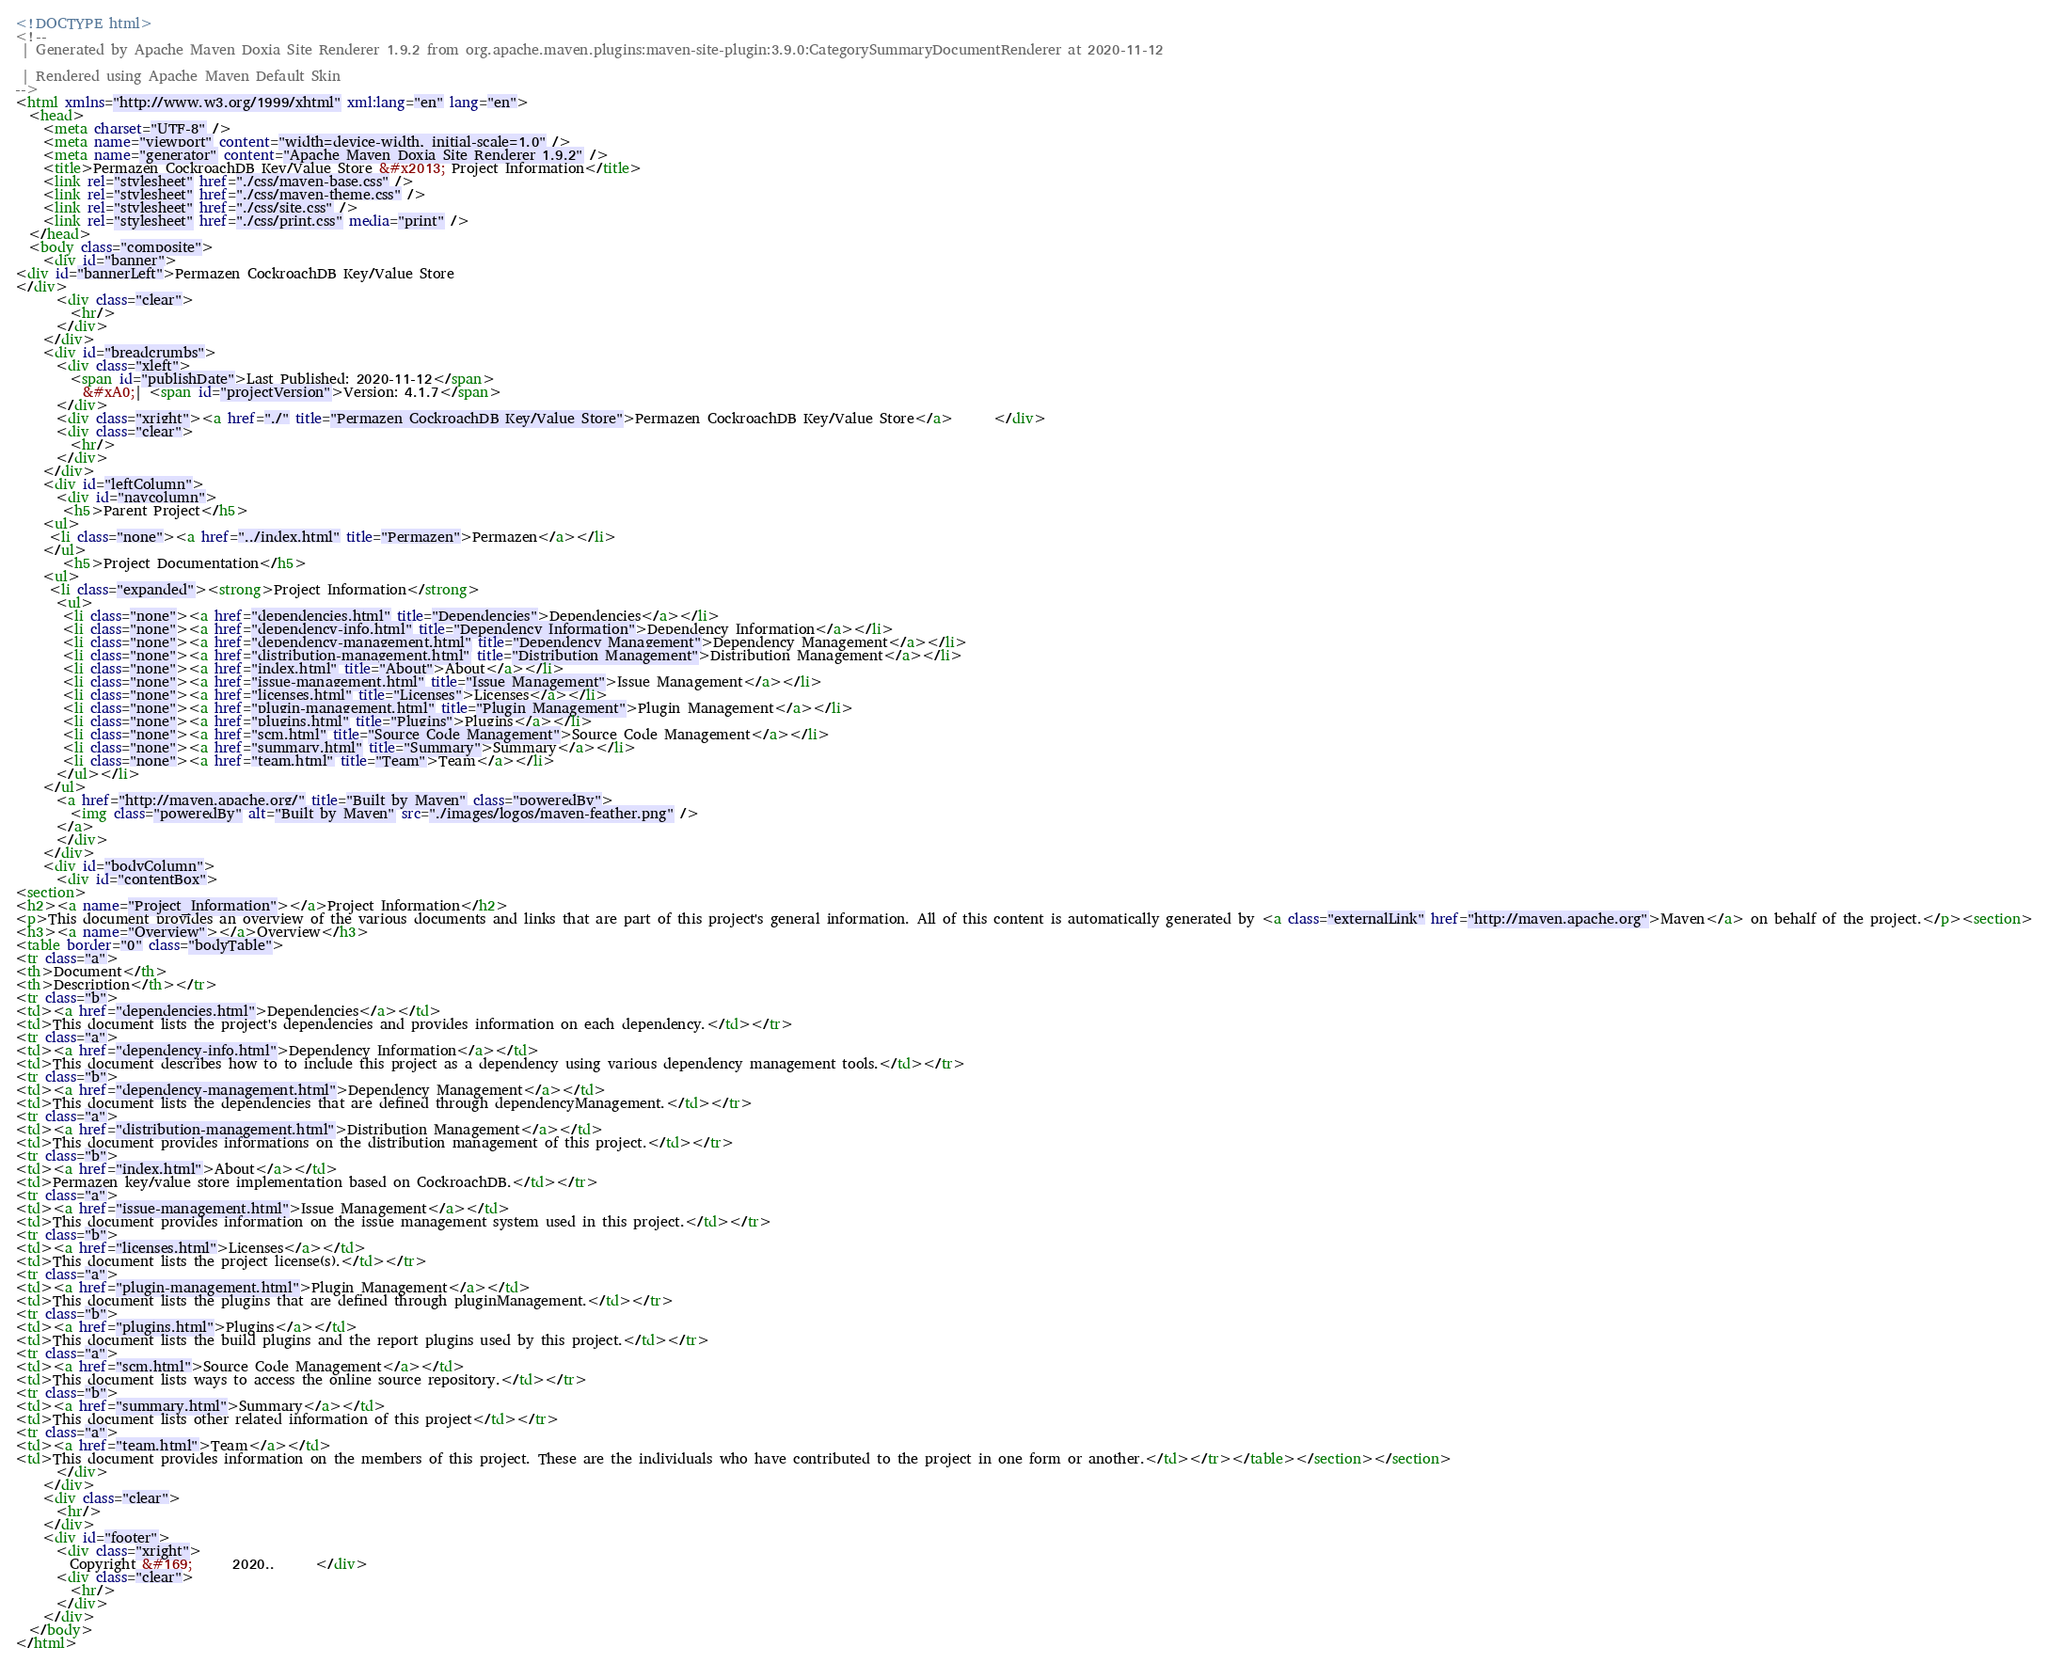<code> <loc_0><loc_0><loc_500><loc_500><_HTML_><!DOCTYPE html>
<!--
 | Generated by Apache Maven Doxia Site Renderer 1.9.2 from org.apache.maven.plugins:maven-site-plugin:3.9.0:CategorySummaryDocumentRenderer at 2020-11-12

 | Rendered using Apache Maven Default Skin
-->
<html xmlns="http://www.w3.org/1999/xhtml" xml:lang="en" lang="en">
  <head>
    <meta charset="UTF-8" />
    <meta name="viewport" content="width=device-width, initial-scale=1.0" />
    <meta name="generator" content="Apache Maven Doxia Site Renderer 1.9.2" />
    <title>Permazen CockroachDB Key/Value Store &#x2013; Project Information</title>
    <link rel="stylesheet" href="./css/maven-base.css" />
    <link rel="stylesheet" href="./css/maven-theme.css" />
    <link rel="stylesheet" href="./css/site.css" />
    <link rel="stylesheet" href="./css/print.css" media="print" />
  </head>
  <body class="composite">
    <div id="banner">
<div id="bannerLeft">Permazen CockroachDB Key/Value Store
</div>
      <div class="clear">
        <hr/>
      </div>
    </div>
    <div id="breadcrumbs">
      <div class="xleft">
        <span id="publishDate">Last Published: 2020-11-12</span>
          &#xA0;| <span id="projectVersion">Version: 4.1.7</span>
      </div>
      <div class="xright"><a href="./" title="Permazen CockroachDB Key/Value Store">Permazen CockroachDB Key/Value Store</a>      </div>
      <div class="clear">
        <hr/>
      </div>
    </div>
    <div id="leftColumn">
      <div id="navcolumn">
       <h5>Parent Project</h5>
    <ul>
     <li class="none"><a href="../index.html" title="Permazen">Permazen</a></li>
    </ul>
       <h5>Project Documentation</h5>
    <ul>
     <li class="expanded"><strong>Project Information</strong>
      <ul>
       <li class="none"><a href="dependencies.html" title="Dependencies">Dependencies</a></li>
       <li class="none"><a href="dependency-info.html" title="Dependency Information">Dependency Information</a></li>
       <li class="none"><a href="dependency-management.html" title="Dependency Management">Dependency Management</a></li>
       <li class="none"><a href="distribution-management.html" title="Distribution Management">Distribution Management</a></li>
       <li class="none"><a href="index.html" title="About">About</a></li>
       <li class="none"><a href="issue-management.html" title="Issue Management">Issue Management</a></li>
       <li class="none"><a href="licenses.html" title="Licenses">Licenses</a></li>
       <li class="none"><a href="plugin-management.html" title="Plugin Management">Plugin Management</a></li>
       <li class="none"><a href="plugins.html" title="Plugins">Plugins</a></li>
       <li class="none"><a href="scm.html" title="Source Code Management">Source Code Management</a></li>
       <li class="none"><a href="summary.html" title="Summary">Summary</a></li>
       <li class="none"><a href="team.html" title="Team">Team</a></li>
      </ul></li>
    </ul>
      <a href="http://maven.apache.org/" title="Built by Maven" class="poweredBy">
        <img class="poweredBy" alt="Built by Maven" src="./images/logos/maven-feather.png" />
      </a>
      </div>
    </div>
    <div id="bodyColumn">
      <div id="contentBox">
<section>
<h2><a name="Project_Information"></a>Project Information</h2>
<p>This document provides an overview of the various documents and links that are part of this project's general information. All of this content is automatically generated by <a class="externalLink" href="http://maven.apache.org">Maven</a> on behalf of the project.</p><section>
<h3><a name="Overview"></a>Overview</h3>
<table border="0" class="bodyTable">
<tr class="a">
<th>Document</th>
<th>Description</th></tr>
<tr class="b">
<td><a href="dependencies.html">Dependencies</a></td>
<td>This document lists the project's dependencies and provides information on each dependency.</td></tr>
<tr class="a">
<td><a href="dependency-info.html">Dependency Information</a></td>
<td>This document describes how to to include this project as a dependency using various dependency management tools.</td></tr>
<tr class="b">
<td><a href="dependency-management.html">Dependency Management</a></td>
<td>This document lists the dependencies that are defined through dependencyManagement.</td></tr>
<tr class="a">
<td><a href="distribution-management.html">Distribution Management</a></td>
<td>This document provides informations on the distribution management of this project.</td></tr>
<tr class="b">
<td><a href="index.html">About</a></td>
<td>Permazen key/value store implementation based on CockroachDB.</td></tr>
<tr class="a">
<td><a href="issue-management.html">Issue Management</a></td>
<td>This document provides information on the issue management system used in this project.</td></tr>
<tr class="b">
<td><a href="licenses.html">Licenses</a></td>
<td>This document lists the project license(s).</td></tr>
<tr class="a">
<td><a href="plugin-management.html">Plugin Management</a></td>
<td>This document lists the plugins that are defined through pluginManagement.</td></tr>
<tr class="b">
<td><a href="plugins.html">Plugins</a></td>
<td>This document lists the build plugins and the report plugins used by this project.</td></tr>
<tr class="a">
<td><a href="scm.html">Source Code Management</a></td>
<td>This document lists ways to access the online source repository.</td></tr>
<tr class="b">
<td><a href="summary.html">Summary</a></td>
<td>This document lists other related information of this project</td></tr>
<tr class="a">
<td><a href="team.html">Team</a></td>
<td>This document provides information on the members of this project. These are the individuals who have contributed to the project in one form or another.</td></tr></table></section></section>
      </div>
    </div>
    <div class="clear">
      <hr/>
    </div>
    <div id="footer">
      <div class="xright">
        Copyright &#169;      2020..      </div>
      <div class="clear">
        <hr/>
      </div>
    </div>
  </body>
</html>
</code> 